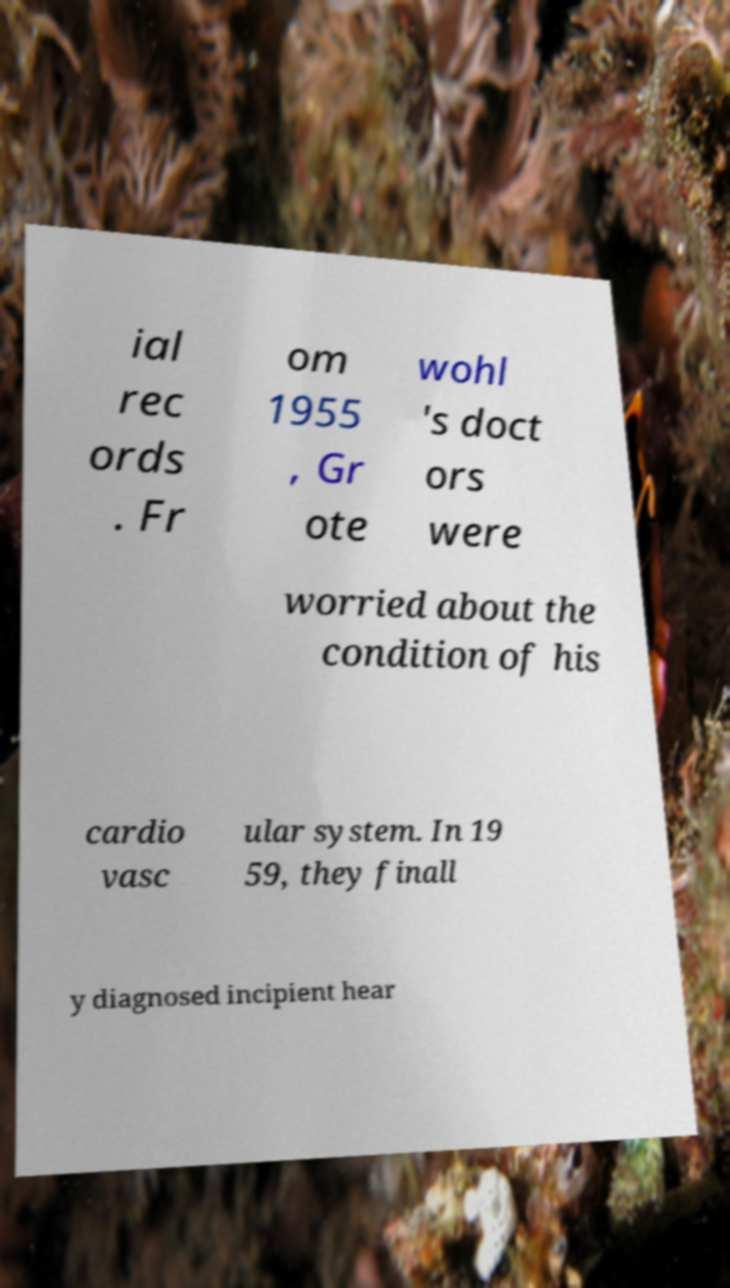Can you accurately transcribe the text from the provided image for me? ial rec ords . Fr om 1955 , Gr ote wohl 's doct ors were worried about the condition of his cardio vasc ular system. In 19 59, they finall y diagnosed incipient hear 